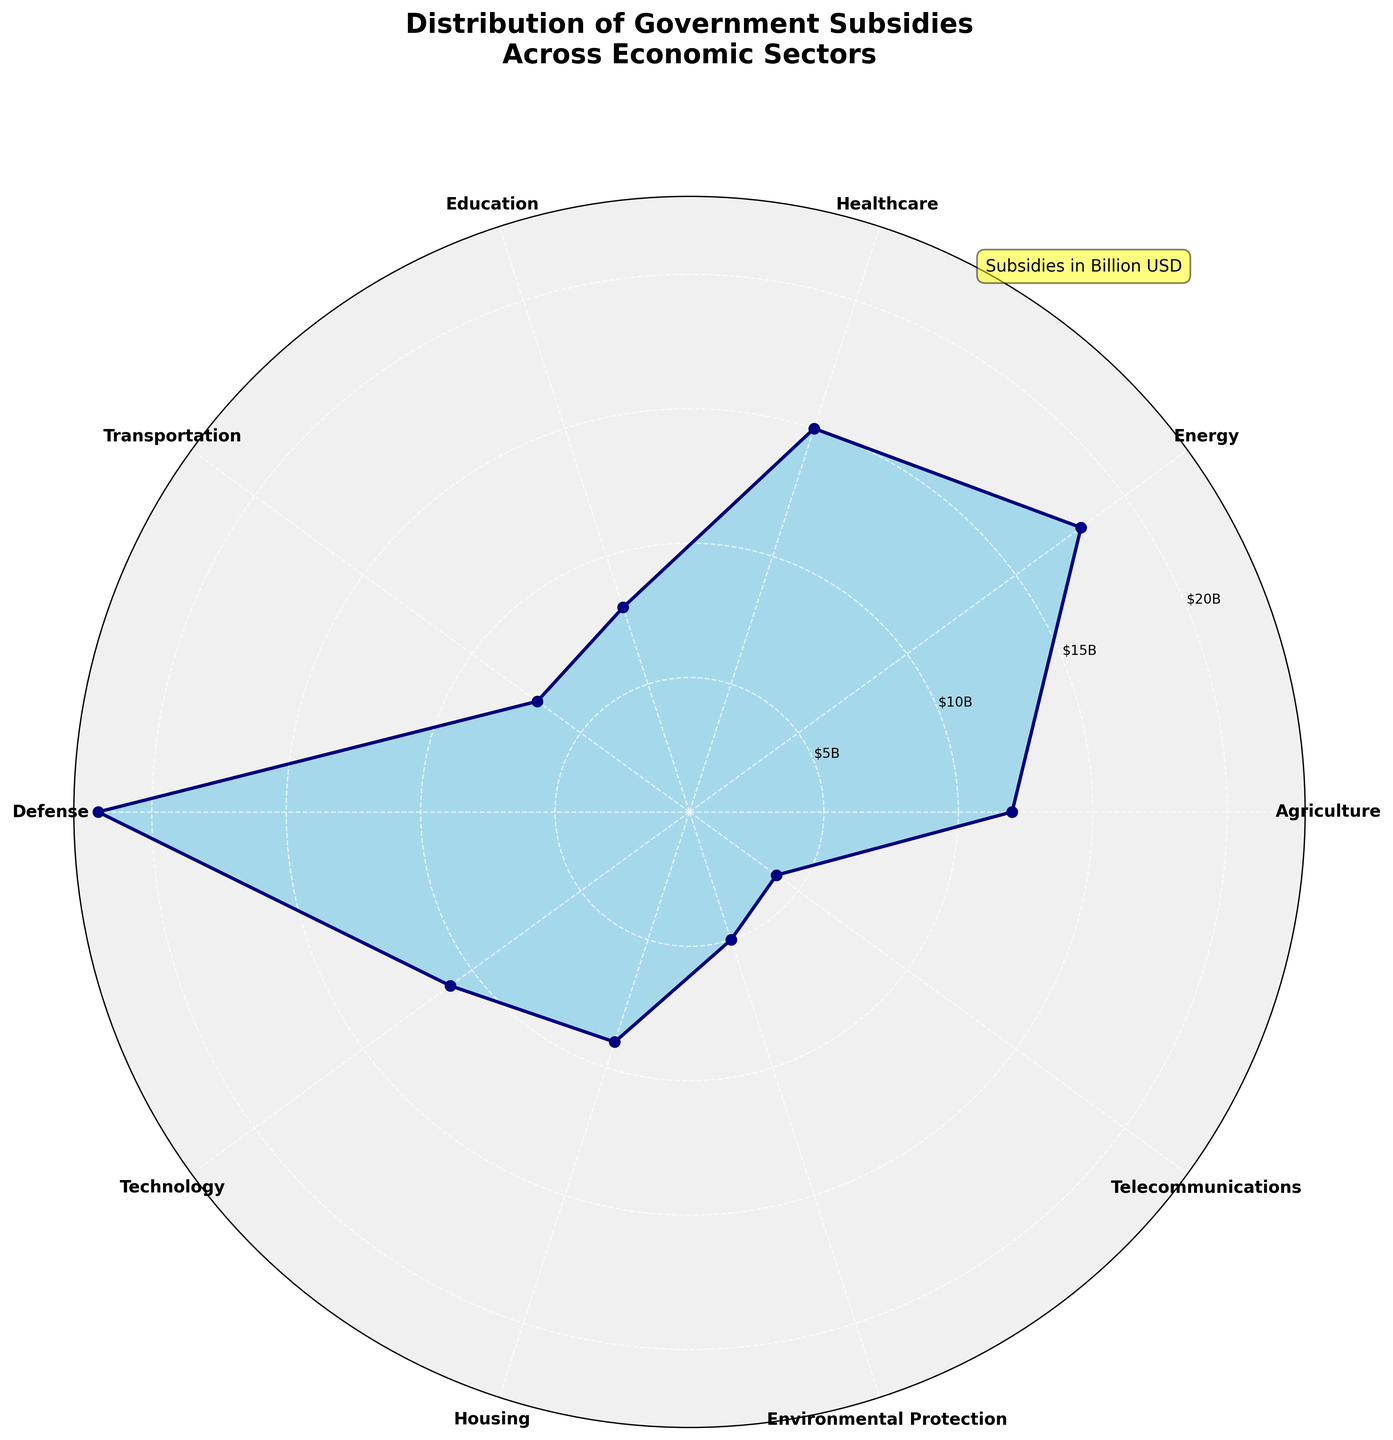What's the title of the figure? The title is usually found at the top or close to the center of the figure and helps identify what the figure is about. In this case, it is clearly stated at the top of the chart.
Answer: "Distribution of Government Subsidies Across Economic Sectors" What is the maximum government subsidy amount and which sector does it belong to? By observing the plotted data, the highest point on the radial axis represents the maximum subsidy amount. The label on the outer edge associated with this point indicates the sector.
Answer: $22B, Defense How many sectors received government subsidies of at least $10 billion? Count the number of data points (angles) where the radius (subsidy amount) is 10 billion dollars or more. Ensure proper conversion from million dollars if needed.
Answer: 5 sectors What is the total amount of subsidies provided to Agriculture, Healthcare, and Education sectors combined? Identify and sum the values for these sectors from the chart. Agriculture: $12B, Healthcare: $15B, Education: $8B. The total is 12 + 15 + 8.
Answer: $35B Which sector has received the least amount of subsidies and what is the amount? Look for the smallest value on the radial axis, and the associated sector label on the edge of the plot. In this case, the smallest segment is clearly visible.
Answer: Telecommunications, $4B By how much does the subsidy amount for Defense exceed that for Environmental Protection? Identify the subsidy amounts for Defense ($22B) and Environmental Protection ($5B), then subtract the smaller amount from the larger amount.
Answer: $17B Are there more sectors with subsidies above or below $10 billion? Count the number of sectors with subsidies greater than $10 billion and those with less. Compare the two counts.
Answer: More below $10B What is the average subsidy amount for all sectors? Sum up all the subsidy amounts and divide by the number of sectors. Sum = 12000 + 18000 + 15000 + 8000 + 7000 + 22000 + 11000 + 9000 + 5000 + 4000. Total sectors = 10. Average = Total sum/Number of sectors.
Answer: $11.6B What is the second highest government subsidy amount and which sector does it belong to? Identify the highest amount first ($22B, Defense) and then find the next highest value on the radial axis and its corresponding sector.
Answer: $18B, Energy 